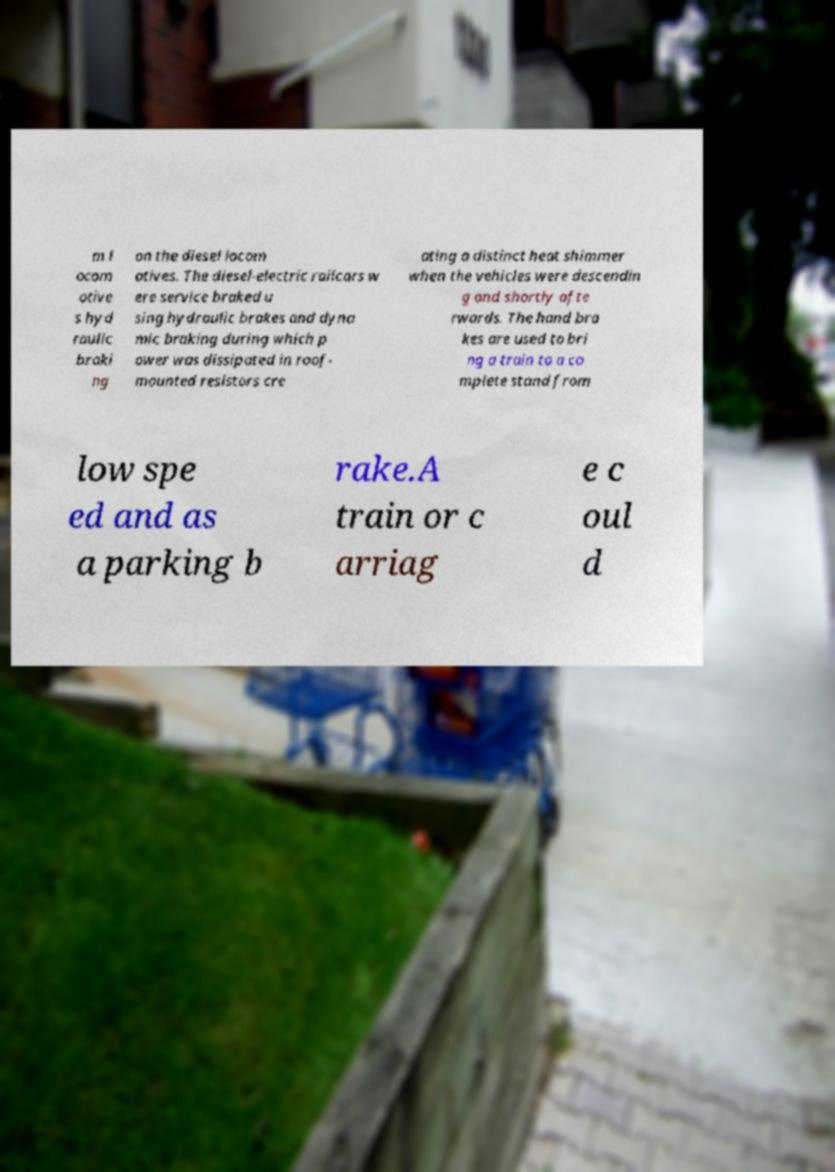Can you accurately transcribe the text from the provided image for me? m l ocom otive s hyd raulic braki ng on the diesel locom otives. The diesel-electric railcars w ere service braked u sing hydraulic brakes and dyna mic braking during which p ower was dissipated in roof- mounted resistors cre ating a distinct heat shimmer when the vehicles were descendin g and shortly afte rwards. The hand bra kes are used to bri ng a train to a co mplete stand from low spe ed and as a parking b rake.A train or c arriag e c oul d 